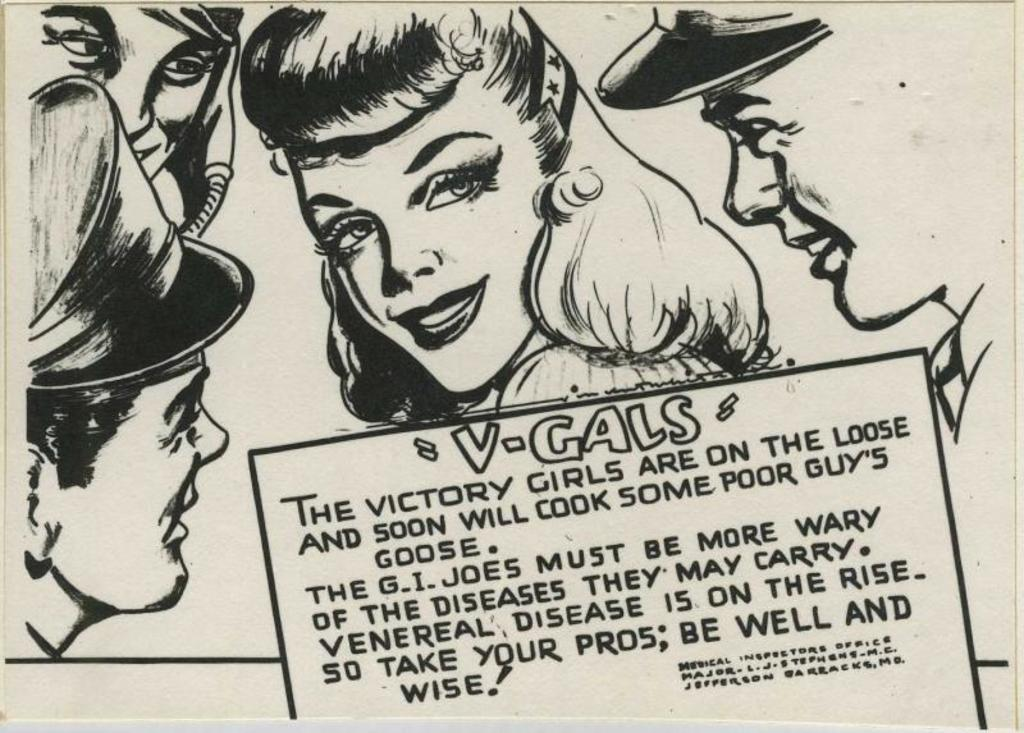What is the main subject of the image? The main subject of the image is an article. What can be seen in the article? The article contains faces of persons arranged one beside the other. Is there any text in the article besides the faces? Yes, there is text at the bottom of the article. How does the mist affect the blade in the image? There is no mist or blade present in the image; it features an article with faces of persons and text. 